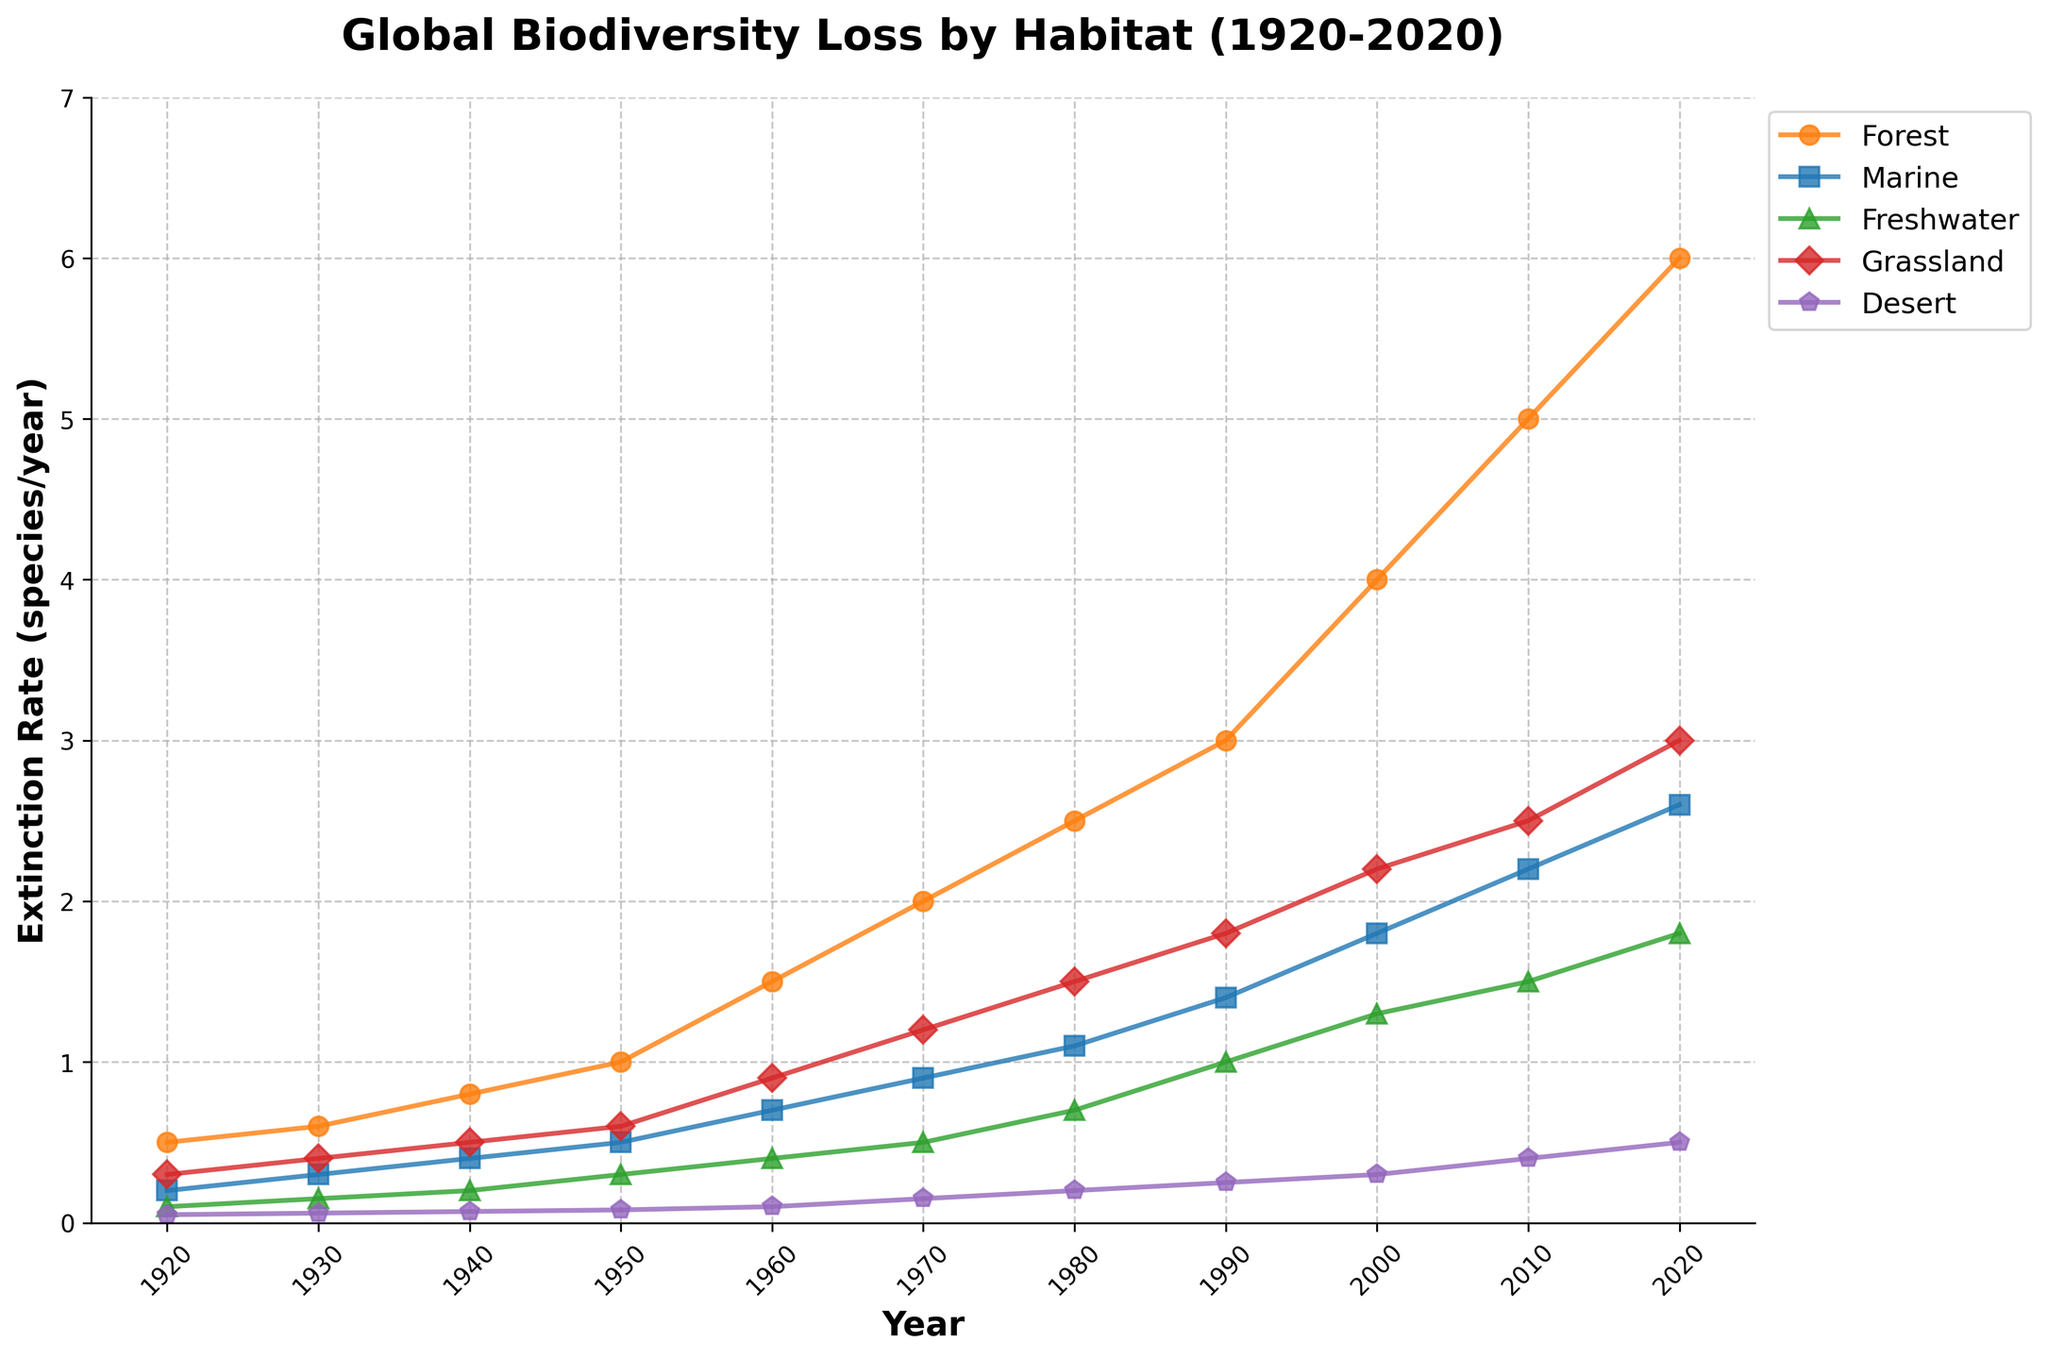What is the title of the figure? The title of the figure is located at the top and reads "Global Biodiversity Loss by Habitat (1920-2020)".
Answer: Global Biodiversity Loss by Habitat (1920-2020) What are the units used on the y-axis? The y-axis indicates the extinction rate, measured in species per year. This is specified by the label "Extinction Rate (species/year)".
Answer: Extinction Rate (species/year) Which habitat had the highest extinction rate in the year 2020? Look at the data points for each habitat in the year 2020. The Forest habitat has the highest extinction rate of 6 species per year.
Answer: Forest How has the Marine extinction rate changed from 1950 to 1960? Compare the Marine extinction rates in 1950 and 1960. It increased from 0.5 species/year in 1950 to 0.7 species/year in 1960.
Answer: Increased from 0.5 to 0.7 species/year Between which decades did the Grassland extinction rate experience the greatest increase? Calculate the differences between each decade's Grassland extinction rates. The greatest increase is between 1990 (1.8) and 2000 (2.2), an increase of 0.4 species/year.
Answer: Between 1990 and 2000 What is the average extinction rate for the Freshwater habitat over the entire period? Add up all the Freshwater extinction rates and divide by the number of periods. Total is 0.1 + 0.15 + 0.2 + 0.3 + 0.4 + 0.5 + 0.7 + 1.0 + 1.3 + 1.5 + 1.8 = 7.95. There are 11 periods, so 7.95 / 11 = 0.7227 species/year.
Answer: 0.72 species/year How does the Forest extinction rate in 1980 compare with the Marine extinction rate in 2010? The Forest extinction rate in 1980 is 2.5 species/year, whereas the Marine extinction rate in 2010 is 2.2 species/year. Forest is higher.
Answer: Forest is higher Which habitat showed the most consistent increase in extinction rates over the century? Check the lines for each habitat to determine which has the most continuous and smooth increase. The Forest habitat consistently increases in extinction rate each decade.
Answer: Forest Which habitat had the lowest extinction rate in 1950? Observe the data points in the year 1950 for each habitat. The Desert habitat had the lowest extinction rate at 0.08 species/year.
Answer: Desert 